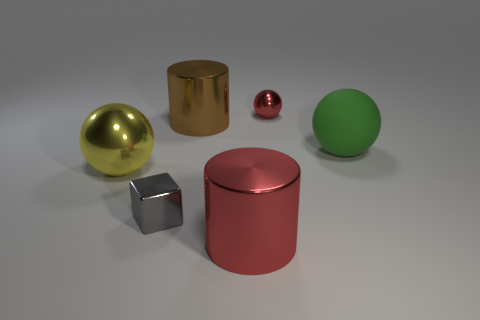There is a big shiny cylinder that is behind the red object that is to the left of the small object right of the cube; what is its color?
Make the answer very short. Brown. Are the big green sphere and the block made of the same material?
Provide a succinct answer. No. There is a big shiny object that is in front of the metal object left of the gray metal cube; is there a shiny cylinder right of it?
Provide a succinct answer. No. Is the color of the tiny block the same as the big rubber thing?
Offer a terse response. No. Are there fewer big purple matte objects than red cylinders?
Your answer should be compact. Yes. Is the thing that is in front of the metal cube made of the same material as the sphere that is on the left side of the small shiny ball?
Give a very brief answer. Yes. Are there fewer small gray metal blocks to the right of the gray shiny thing than large cubes?
Your answer should be compact. No. What number of brown things are on the right side of the tiny object that is on the right side of the gray object?
Make the answer very short. 0. What size is the metallic thing that is both left of the big red cylinder and behind the green sphere?
Your response must be concise. Large. Is there any other thing that is the same material as the small gray thing?
Your answer should be very brief. Yes. 